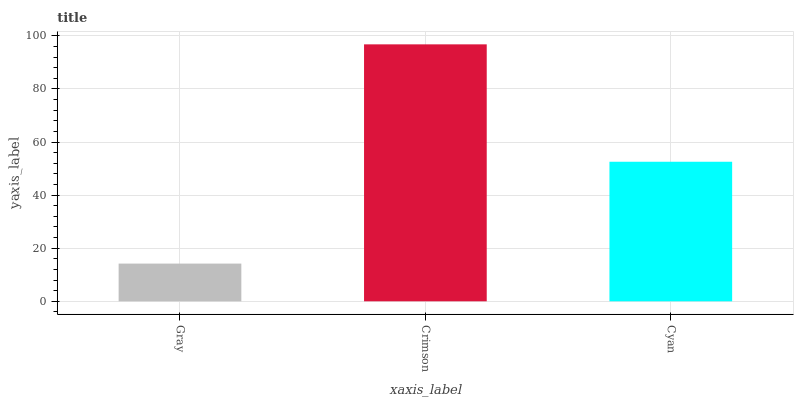Is Cyan the minimum?
Answer yes or no. No. Is Cyan the maximum?
Answer yes or no. No. Is Crimson greater than Cyan?
Answer yes or no. Yes. Is Cyan less than Crimson?
Answer yes or no. Yes. Is Cyan greater than Crimson?
Answer yes or no. No. Is Crimson less than Cyan?
Answer yes or no. No. Is Cyan the high median?
Answer yes or no. Yes. Is Cyan the low median?
Answer yes or no. Yes. Is Gray the high median?
Answer yes or no. No. Is Crimson the low median?
Answer yes or no. No. 